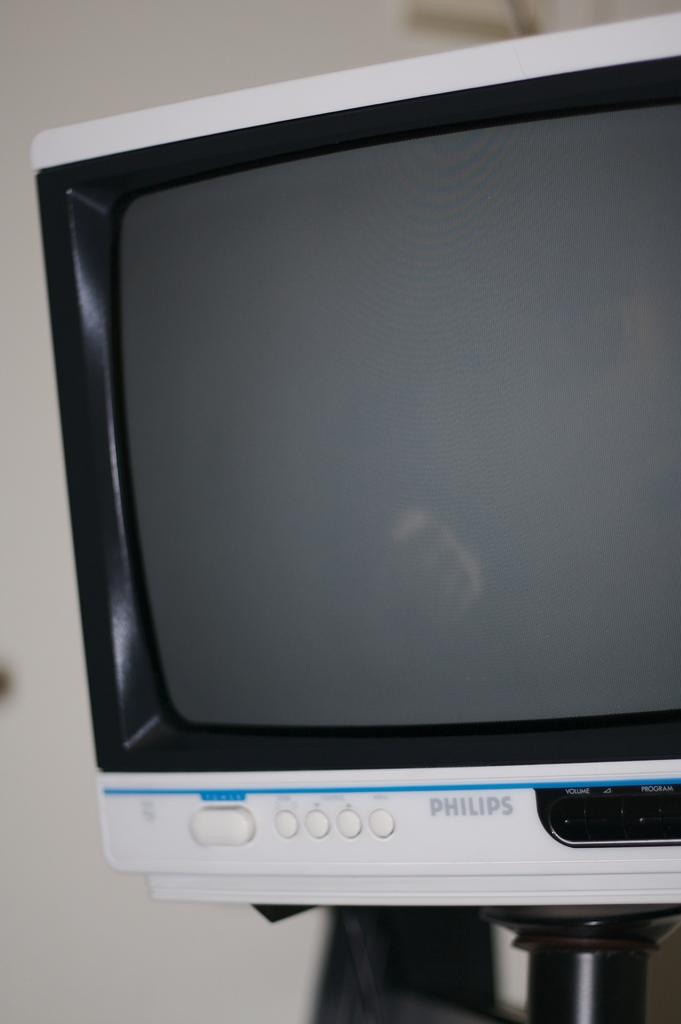<image>
Create a compact narrative representing the image presented. An old Philips television hangs on a wall. 